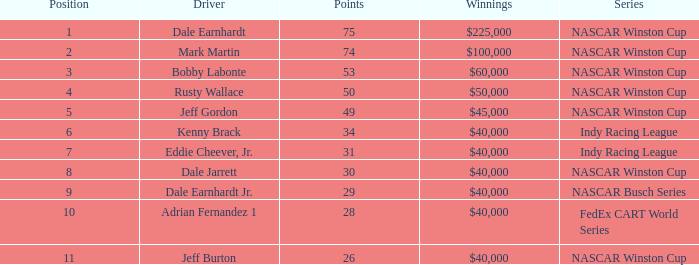At what ranking did the driver accumulate 31 points? 7.0. 